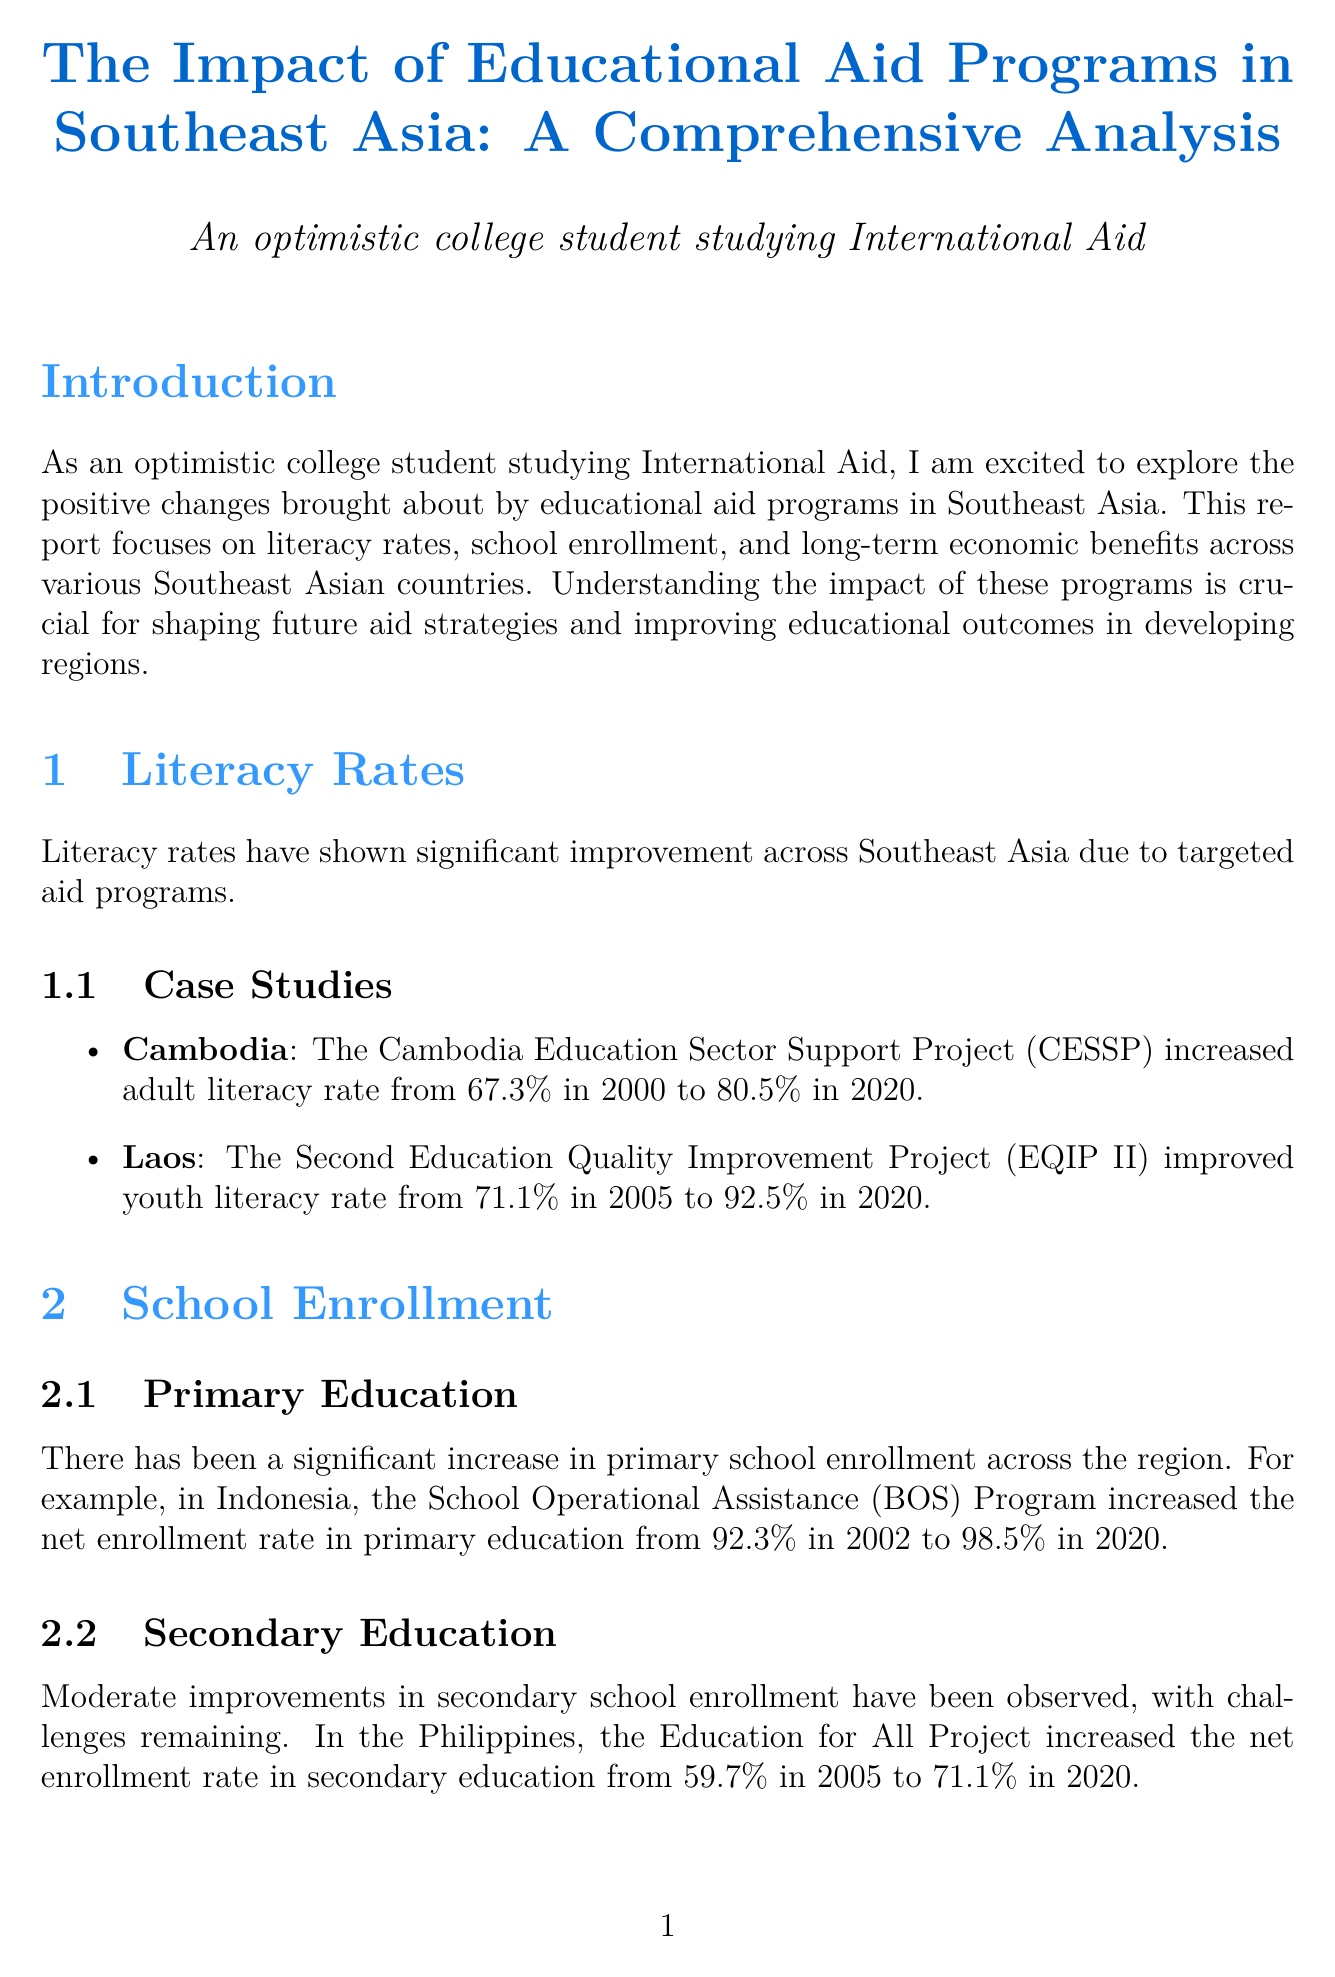What is the title of the report? The title of the report is mentioned at the beginning and is, "The Impact of Educational Aid Programs in Southeast Asia: A Comprehensive Analysis."
Answer: The Impact of Educational Aid Programs in Southeast Asia: A Comprehensive Analysis Which country experienced a rise in adult literacy from 67.3% to 80.5%? The report discusses Cambodia's progress in literacy rates, specifically mentioning the increase from 67.3% to 80.5%.
Answer: Cambodia What was the net enrollment rate in primary education in Indonesia in 2020? The document provides the net enrollment rate for primary education in Indonesia, stated to be 98.5% in 2020.
Answer: 98.5% What key finding relates to income inequality? The report lists several key findings about the effects of educational aid, including that it has led to reduced income inequality.
Answer: Reduced income inequality What was the poverty rate decrease in Vietnam from 2002 to 2020? The report specifies that the poverty rate in Vietnam decreased from 28.9% in 2002 to 5.8% in 2020.
Answer: 5.8% What is one of the challenges mentioned in implementing educational aid programs? The document outlines several challenges, one of which is reaching remote and marginalized communities.
Answer: Reaching remote and marginalized communities Which educational program in Laos improved youth literacy from 71.1% to 92.5%? The report identifies the Second Education Quality Improvement Project (EQIP II) as the program that improved youth literacy in Laos.
Answer: Second Education Quality Improvement Project (EQIP II) What significant economic growth indicator improved in Vietnam as outlined in the report? The document highlights GDP growth rate as an important economic indicator that improved in Vietnam due to educational aid programs.
Answer: GDP growth rate 